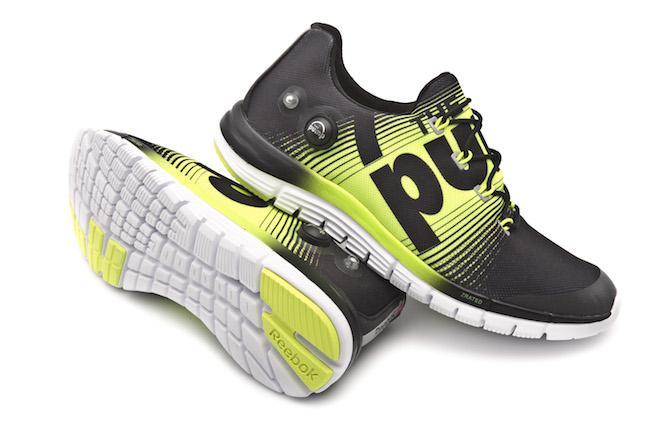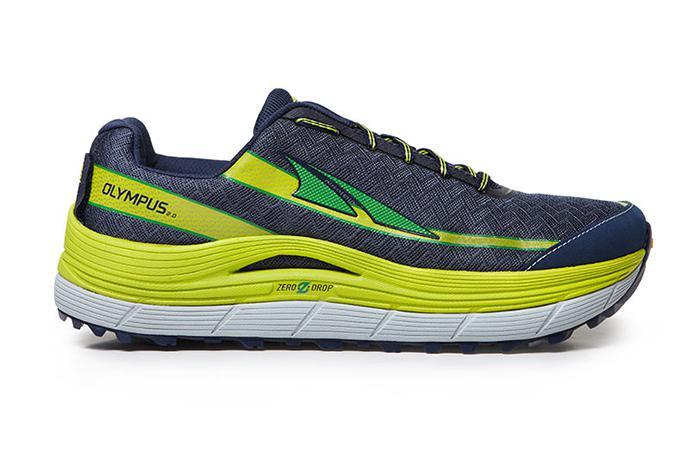The first image is the image on the left, the second image is the image on the right. For the images shown, is this caption "The image contains two brightly colored shoes stacked on top of eachother." true? Answer yes or no. Yes. The first image is the image on the left, the second image is the image on the right. Analyze the images presented: Is the assertion "In at least one image there is one shoe that is sitting on top of another shoe." valid? Answer yes or no. Yes. 